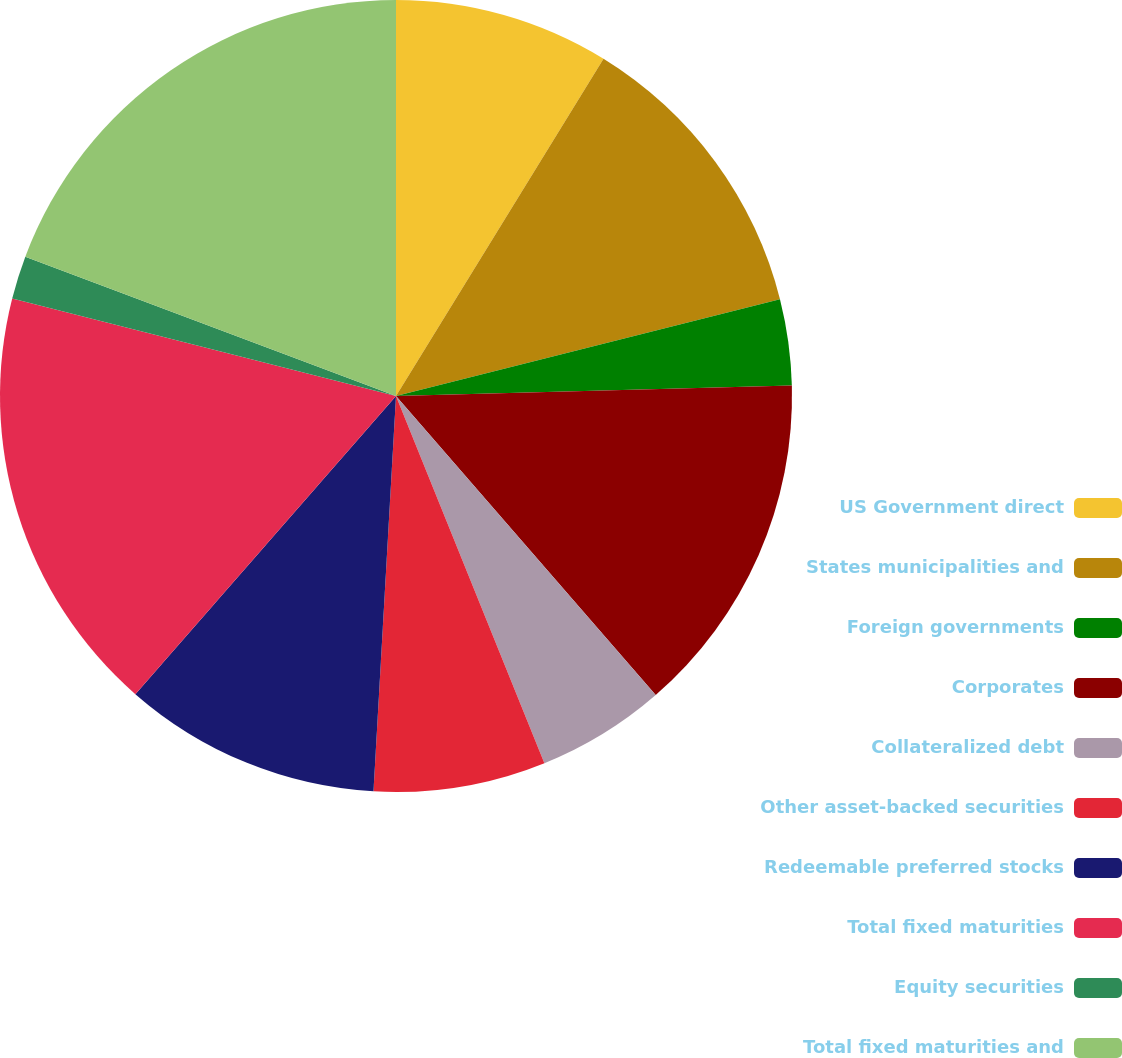<chart> <loc_0><loc_0><loc_500><loc_500><pie_chart><fcel>US Government direct<fcel>States municipalities and<fcel>Foreign governments<fcel>Corporates<fcel>Collateralized debt<fcel>Other asset-backed securities<fcel>Redeemable preferred stocks<fcel>Total fixed maturities<fcel>Equity securities<fcel>Total fixed maturities and<nl><fcel>8.78%<fcel>12.29%<fcel>3.51%<fcel>14.04%<fcel>5.27%<fcel>7.02%<fcel>10.53%<fcel>17.53%<fcel>1.76%<fcel>19.28%<nl></chart> 